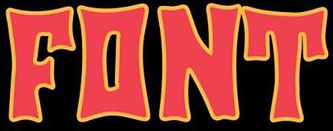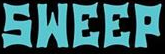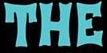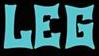What text appears in these images from left to right, separated by a semicolon? FONT; SWEEP; THE; LEG 